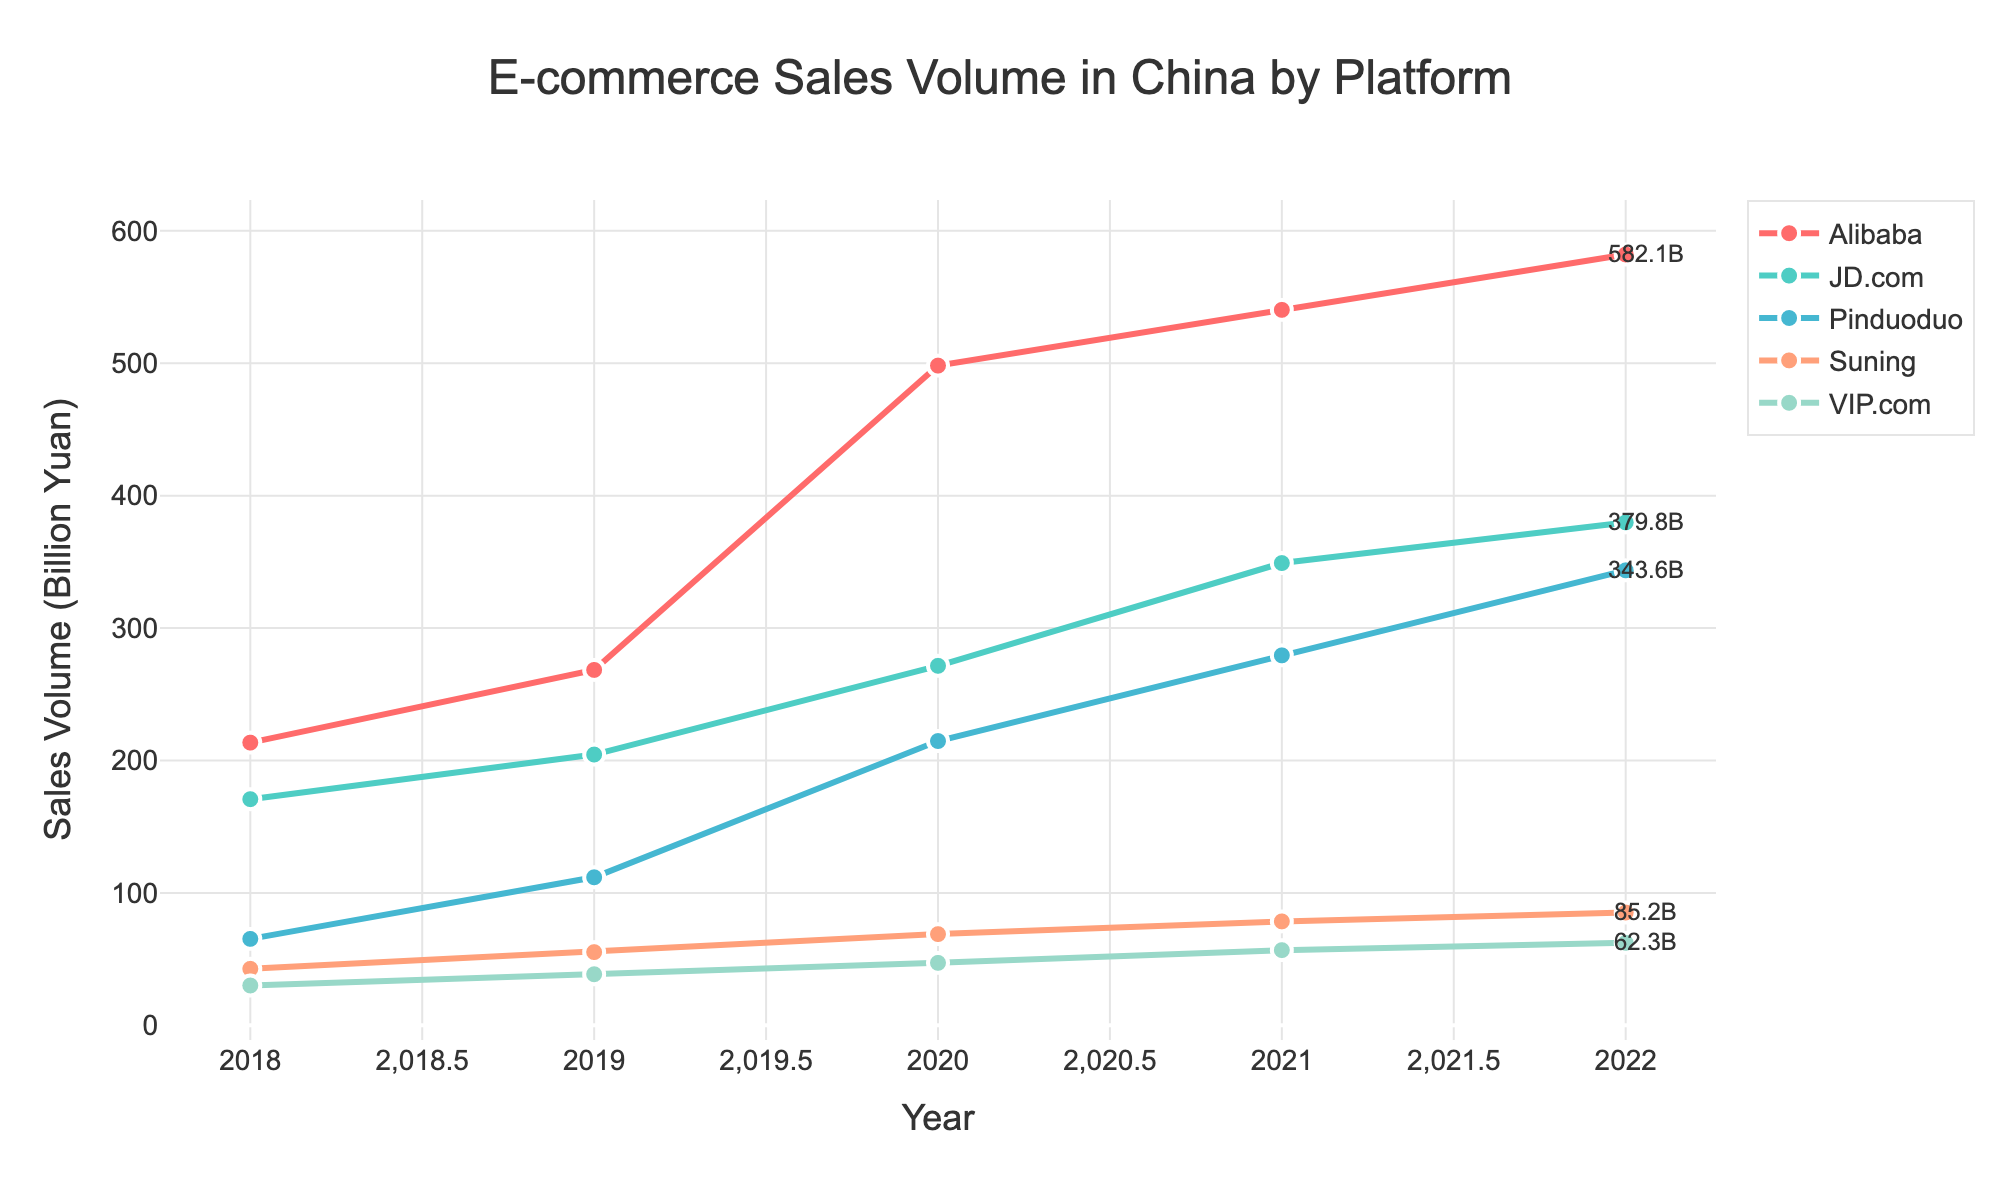What was the e-commerce sales volume for Alibaba in 2020? Look at the line for Alibaba and locate the value at the year 2020.
Answer: 498.2 How much did JD.com's sales volume increase from 2018 to 2022? Find the sales volume for JD.com in 2018 (170.8) and 2022 (379.8). Subtract the 2018 value from the 2022 value.
Answer: 209.0 Which platform had the highest sales volume in 2022? Compare the sales volumes of all platforms for the year 2022.
Answer: Alibaba Among the platforms listed, which one had the lowest increase in sales volume from 2018 to 2022? Calculate the increase for each platform by subtracting their 2018 values from their 2022 values. Compare these increases.
Answer: Suning What's the difference in sales volume between JD.com and Pinduoduo in 2021? Locate the values for JD.com (349.1) and Pinduoduo (279.4) for 2021 and subtract the latter from the former.
Answer: 69.7 Which year's data is represented by the largest gap between Alibaba’s and Pinduoduo’s sales volumes? For each year, subtract Pinduoduo’s sales volume from Alibaba’s and find the year with the largest difference.
Answer: 2022 Combine the sales volumes of VIP.com and Suning for 2019. What's the total? Add the sales volumes of VIP.com (38.6) and Suning (55.3) for 2019.
Answer: 93.9 Between 2019 and 2020, which platform saw the highest relative growth in sales volume? Calculate the percentage growth for each platform from 2019 to 2020: [(2020 value - 2019 value) / 2019 value] * 100%. Find the highest percentage.
Answer: Pinduoduo Visually, which platform's sales volume shows the most consistent increase over the years? Look at the lines for all platforms and determine which one increases most steadily without major fluctuations.
Answer: Alibaba How does the sales volume of VIP.com in 2022 compare to its volume in 2018? Compare the sales volumes of VIP.com in 2018 (30.1) and 2022 (62.3). Notice the increase and relative growth.
Answer: Increased 